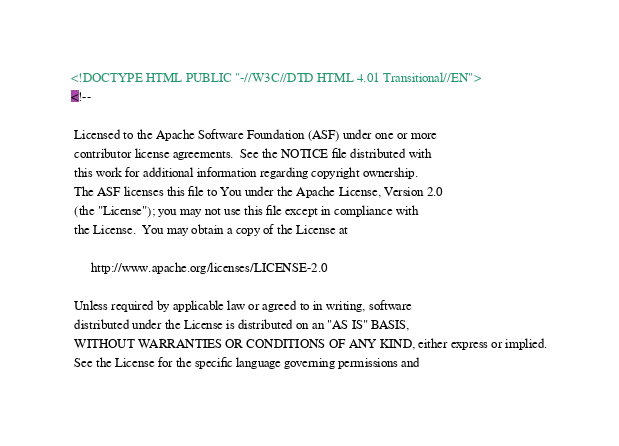Convert code to text. <code><loc_0><loc_0><loc_500><loc_500><_HTML_><!DOCTYPE HTML PUBLIC "-//W3C//DTD HTML 4.01 Transitional//EN">
<!--

 Licensed to the Apache Software Foundation (ASF) under one or more
 contributor license agreements.  See the NOTICE file distributed with
 this work for additional information regarding copyright ownership.
 The ASF licenses this file to You under the Apache License, Version 2.0
 (the "License"); you may not use this file except in compliance with
 the License.  You may obtain a copy of the License at

      http://www.apache.org/licenses/LICENSE-2.0

 Unless required by applicable law or agreed to in writing, software
 distributed under the License is distributed on an "AS IS" BASIS,
 WITHOUT WARRANTIES OR CONDITIONS OF ANY KIND, either express or implied.
 See the License for the specific language governing permissions and</code> 